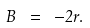<formula> <loc_0><loc_0><loc_500><loc_500>B \ = \ - 2 r .</formula> 